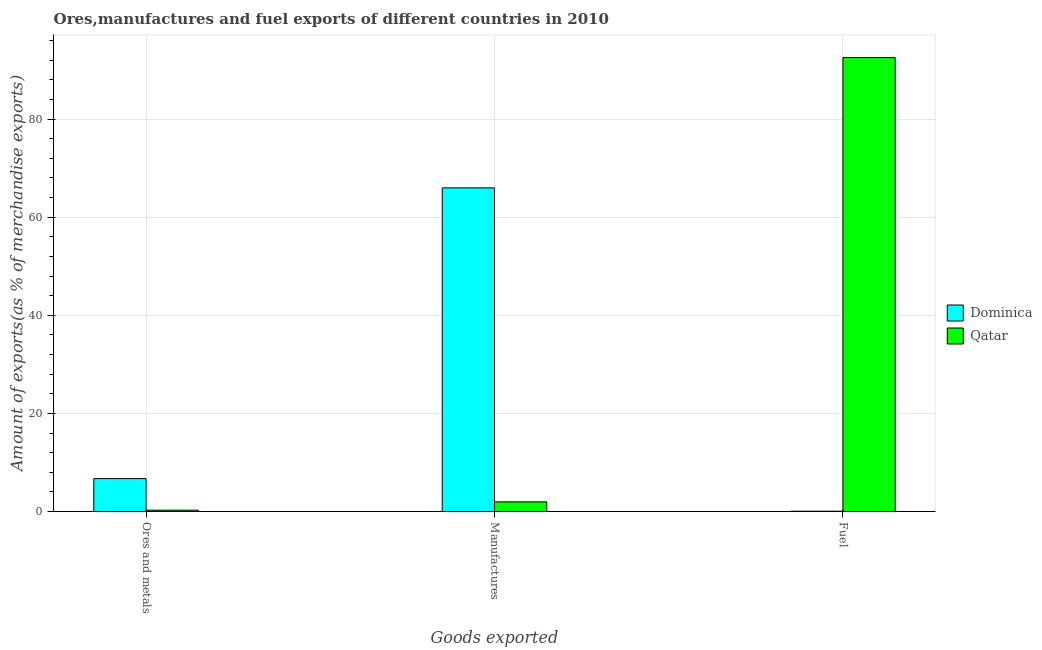Are the number of bars per tick equal to the number of legend labels?
Offer a very short reply. Yes. What is the label of the 3rd group of bars from the left?
Provide a succinct answer. Fuel. What is the percentage of ores and metals exports in Qatar?
Your response must be concise. 0.27. Across all countries, what is the maximum percentage of fuel exports?
Make the answer very short. 92.55. Across all countries, what is the minimum percentage of fuel exports?
Make the answer very short. 0.05. In which country was the percentage of manufactures exports maximum?
Ensure brevity in your answer.  Dominica. In which country was the percentage of ores and metals exports minimum?
Offer a very short reply. Qatar. What is the total percentage of ores and metals exports in the graph?
Provide a succinct answer. 6.97. What is the difference between the percentage of ores and metals exports in Qatar and that in Dominica?
Your answer should be compact. -6.44. What is the difference between the percentage of ores and metals exports in Dominica and the percentage of manufactures exports in Qatar?
Keep it short and to the point. 4.74. What is the average percentage of ores and metals exports per country?
Your answer should be compact. 3.48. What is the difference between the percentage of manufactures exports and percentage of fuel exports in Dominica?
Your answer should be very brief. 65.94. What is the ratio of the percentage of fuel exports in Qatar to that in Dominica?
Offer a very short reply. 1752.87. What is the difference between the highest and the second highest percentage of fuel exports?
Ensure brevity in your answer.  92.5. What is the difference between the highest and the lowest percentage of ores and metals exports?
Offer a very short reply. 6.44. In how many countries, is the percentage of manufactures exports greater than the average percentage of manufactures exports taken over all countries?
Give a very brief answer. 1. Is the sum of the percentage of fuel exports in Dominica and Qatar greater than the maximum percentage of ores and metals exports across all countries?
Your answer should be very brief. Yes. What does the 2nd bar from the left in Ores and metals represents?
Provide a short and direct response. Qatar. What does the 1st bar from the right in Manufactures represents?
Keep it short and to the point. Qatar. How many bars are there?
Offer a very short reply. 6. How many countries are there in the graph?
Offer a very short reply. 2. What is the difference between two consecutive major ticks on the Y-axis?
Offer a terse response. 20. Are the values on the major ticks of Y-axis written in scientific E-notation?
Make the answer very short. No. Does the graph contain grids?
Provide a short and direct response. Yes. Where does the legend appear in the graph?
Ensure brevity in your answer.  Center right. How are the legend labels stacked?
Your answer should be compact. Vertical. What is the title of the graph?
Ensure brevity in your answer.  Ores,manufactures and fuel exports of different countries in 2010. Does "Iceland" appear as one of the legend labels in the graph?
Your answer should be compact. No. What is the label or title of the X-axis?
Provide a succinct answer. Goods exported. What is the label or title of the Y-axis?
Provide a short and direct response. Amount of exports(as % of merchandise exports). What is the Amount of exports(as % of merchandise exports) of Dominica in Ores and metals?
Make the answer very short. 6.7. What is the Amount of exports(as % of merchandise exports) in Qatar in Ores and metals?
Keep it short and to the point. 0.27. What is the Amount of exports(as % of merchandise exports) of Dominica in Manufactures?
Ensure brevity in your answer.  65.99. What is the Amount of exports(as % of merchandise exports) of Qatar in Manufactures?
Your answer should be very brief. 1.97. What is the Amount of exports(as % of merchandise exports) of Dominica in Fuel?
Ensure brevity in your answer.  0.05. What is the Amount of exports(as % of merchandise exports) of Qatar in Fuel?
Your answer should be compact. 92.55. Across all Goods exported, what is the maximum Amount of exports(as % of merchandise exports) of Dominica?
Your answer should be compact. 65.99. Across all Goods exported, what is the maximum Amount of exports(as % of merchandise exports) of Qatar?
Offer a terse response. 92.55. Across all Goods exported, what is the minimum Amount of exports(as % of merchandise exports) in Dominica?
Ensure brevity in your answer.  0.05. Across all Goods exported, what is the minimum Amount of exports(as % of merchandise exports) in Qatar?
Offer a terse response. 0.27. What is the total Amount of exports(as % of merchandise exports) in Dominica in the graph?
Give a very brief answer. 72.75. What is the total Amount of exports(as % of merchandise exports) in Qatar in the graph?
Provide a short and direct response. 94.79. What is the difference between the Amount of exports(as % of merchandise exports) of Dominica in Ores and metals and that in Manufactures?
Your response must be concise. -59.29. What is the difference between the Amount of exports(as % of merchandise exports) in Qatar in Ores and metals and that in Manufactures?
Your answer should be very brief. -1.7. What is the difference between the Amount of exports(as % of merchandise exports) of Dominica in Ores and metals and that in Fuel?
Give a very brief answer. 6.65. What is the difference between the Amount of exports(as % of merchandise exports) of Qatar in Ores and metals and that in Fuel?
Offer a very short reply. -92.29. What is the difference between the Amount of exports(as % of merchandise exports) of Dominica in Manufactures and that in Fuel?
Make the answer very short. 65.94. What is the difference between the Amount of exports(as % of merchandise exports) in Qatar in Manufactures and that in Fuel?
Your answer should be very brief. -90.59. What is the difference between the Amount of exports(as % of merchandise exports) of Dominica in Ores and metals and the Amount of exports(as % of merchandise exports) of Qatar in Manufactures?
Your answer should be compact. 4.74. What is the difference between the Amount of exports(as % of merchandise exports) of Dominica in Ores and metals and the Amount of exports(as % of merchandise exports) of Qatar in Fuel?
Provide a succinct answer. -85.85. What is the difference between the Amount of exports(as % of merchandise exports) of Dominica in Manufactures and the Amount of exports(as % of merchandise exports) of Qatar in Fuel?
Your answer should be compact. -26.56. What is the average Amount of exports(as % of merchandise exports) of Dominica per Goods exported?
Offer a terse response. 24.25. What is the average Amount of exports(as % of merchandise exports) of Qatar per Goods exported?
Provide a short and direct response. 31.6. What is the difference between the Amount of exports(as % of merchandise exports) of Dominica and Amount of exports(as % of merchandise exports) of Qatar in Ores and metals?
Your answer should be compact. 6.44. What is the difference between the Amount of exports(as % of merchandise exports) of Dominica and Amount of exports(as % of merchandise exports) of Qatar in Manufactures?
Ensure brevity in your answer.  64.02. What is the difference between the Amount of exports(as % of merchandise exports) in Dominica and Amount of exports(as % of merchandise exports) in Qatar in Fuel?
Offer a terse response. -92.5. What is the ratio of the Amount of exports(as % of merchandise exports) in Dominica in Ores and metals to that in Manufactures?
Your answer should be very brief. 0.1. What is the ratio of the Amount of exports(as % of merchandise exports) in Qatar in Ores and metals to that in Manufactures?
Provide a succinct answer. 0.13. What is the ratio of the Amount of exports(as % of merchandise exports) of Dominica in Ores and metals to that in Fuel?
Your answer should be very brief. 126.96. What is the ratio of the Amount of exports(as % of merchandise exports) of Qatar in Ores and metals to that in Fuel?
Give a very brief answer. 0. What is the ratio of the Amount of exports(as % of merchandise exports) of Dominica in Manufactures to that in Fuel?
Your answer should be very brief. 1249.77. What is the ratio of the Amount of exports(as % of merchandise exports) of Qatar in Manufactures to that in Fuel?
Ensure brevity in your answer.  0.02. What is the difference between the highest and the second highest Amount of exports(as % of merchandise exports) of Dominica?
Provide a short and direct response. 59.29. What is the difference between the highest and the second highest Amount of exports(as % of merchandise exports) of Qatar?
Your response must be concise. 90.59. What is the difference between the highest and the lowest Amount of exports(as % of merchandise exports) in Dominica?
Give a very brief answer. 65.94. What is the difference between the highest and the lowest Amount of exports(as % of merchandise exports) of Qatar?
Keep it short and to the point. 92.29. 